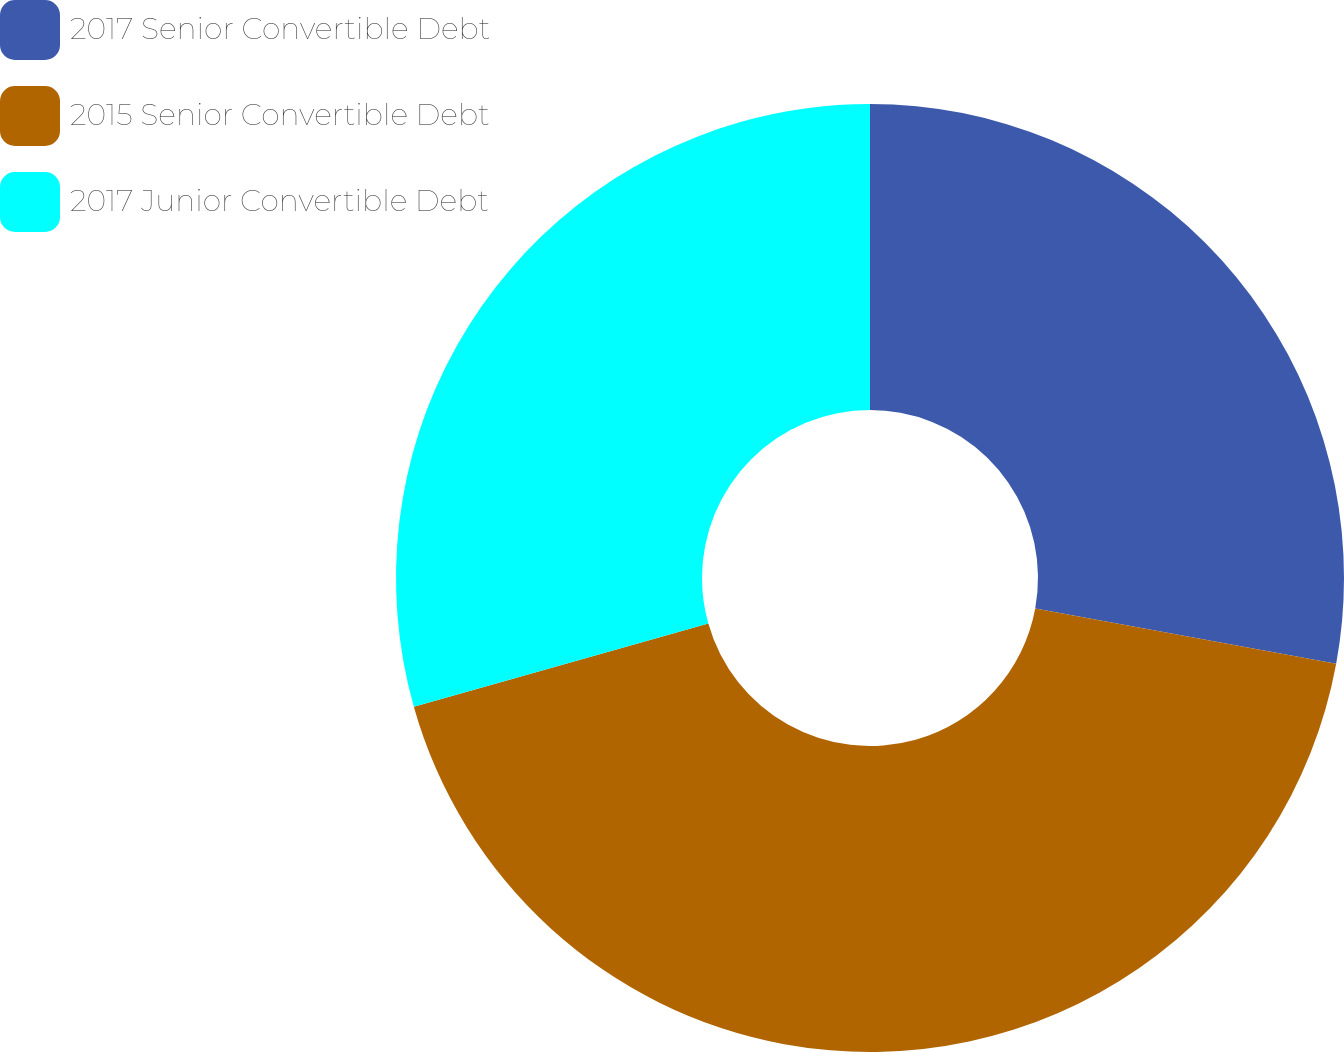Convert chart to OTSL. <chart><loc_0><loc_0><loc_500><loc_500><pie_chart><fcel>2017 Senior Convertible Debt<fcel>2015 Senior Convertible Debt<fcel>2017 Junior Convertible Debt<nl><fcel>27.9%<fcel>42.73%<fcel>29.38%<nl></chart> 